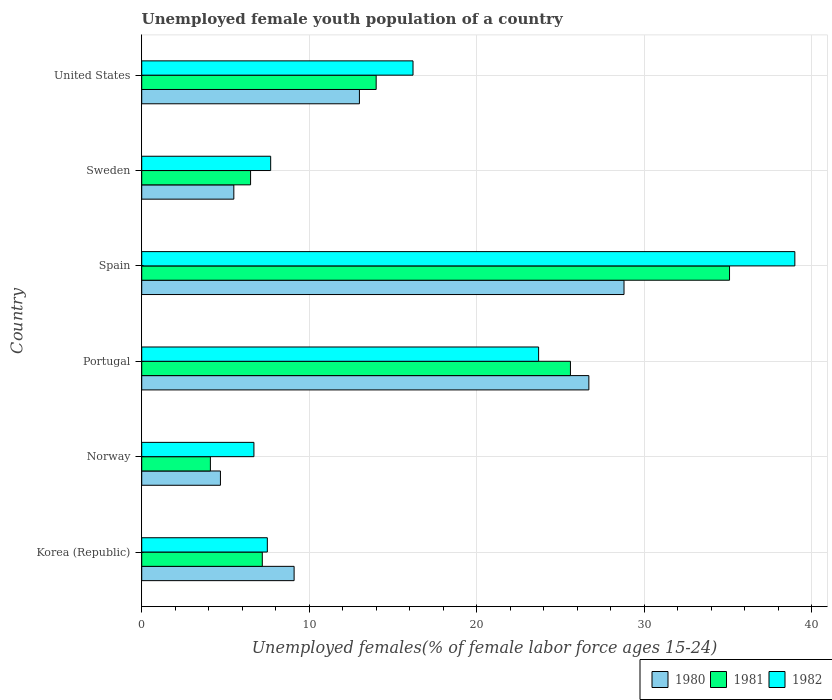Are the number of bars per tick equal to the number of legend labels?
Keep it short and to the point. Yes. How many bars are there on the 6th tick from the top?
Make the answer very short. 3. What is the label of the 1st group of bars from the top?
Give a very brief answer. United States. In how many cases, is the number of bars for a given country not equal to the number of legend labels?
Keep it short and to the point. 0. What is the percentage of unemployed female youth population in 1981 in Norway?
Provide a short and direct response. 4.1. Across all countries, what is the maximum percentage of unemployed female youth population in 1981?
Offer a terse response. 35.1. Across all countries, what is the minimum percentage of unemployed female youth population in 1981?
Your response must be concise. 4.1. In which country was the percentage of unemployed female youth population in 1982 maximum?
Your answer should be very brief. Spain. In which country was the percentage of unemployed female youth population in 1982 minimum?
Keep it short and to the point. Norway. What is the total percentage of unemployed female youth population in 1982 in the graph?
Give a very brief answer. 100.8. What is the difference between the percentage of unemployed female youth population in 1980 in Norway and that in Spain?
Keep it short and to the point. -24.1. What is the difference between the percentage of unemployed female youth population in 1980 in Spain and the percentage of unemployed female youth population in 1981 in Sweden?
Offer a very short reply. 22.3. What is the average percentage of unemployed female youth population in 1982 per country?
Keep it short and to the point. 16.8. What is the difference between the percentage of unemployed female youth population in 1981 and percentage of unemployed female youth population in 1980 in Spain?
Make the answer very short. 6.3. In how many countries, is the percentage of unemployed female youth population in 1982 greater than 4 %?
Your response must be concise. 6. What is the ratio of the percentage of unemployed female youth population in 1981 in Korea (Republic) to that in Norway?
Offer a terse response. 1.76. Is the difference between the percentage of unemployed female youth population in 1981 in Korea (Republic) and United States greater than the difference between the percentage of unemployed female youth population in 1980 in Korea (Republic) and United States?
Offer a very short reply. No. What is the difference between the highest and the second highest percentage of unemployed female youth population in 1981?
Keep it short and to the point. 9.5. What is the difference between the highest and the lowest percentage of unemployed female youth population in 1980?
Your answer should be compact. 24.1. In how many countries, is the percentage of unemployed female youth population in 1981 greater than the average percentage of unemployed female youth population in 1981 taken over all countries?
Provide a succinct answer. 2. Is it the case that in every country, the sum of the percentage of unemployed female youth population in 1981 and percentage of unemployed female youth population in 1980 is greater than the percentage of unemployed female youth population in 1982?
Your answer should be very brief. Yes. How many bars are there?
Your response must be concise. 18. Are all the bars in the graph horizontal?
Ensure brevity in your answer.  Yes. How many countries are there in the graph?
Keep it short and to the point. 6. What is the difference between two consecutive major ticks on the X-axis?
Give a very brief answer. 10. Does the graph contain grids?
Your answer should be very brief. Yes. Where does the legend appear in the graph?
Offer a very short reply. Bottom right. How many legend labels are there?
Provide a short and direct response. 3. What is the title of the graph?
Provide a succinct answer. Unemployed female youth population of a country. What is the label or title of the X-axis?
Provide a succinct answer. Unemployed females(% of female labor force ages 15-24). What is the Unemployed females(% of female labor force ages 15-24) of 1980 in Korea (Republic)?
Offer a very short reply. 9.1. What is the Unemployed females(% of female labor force ages 15-24) in 1981 in Korea (Republic)?
Your answer should be compact. 7.2. What is the Unemployed females(% of female labor force ages 15-24) of 1980 in Norway?
Make the answer very short. 4.7. What is the Unemployed females(% of female labor force ages 15-24) of 1981 in Norway?
Keep it short and to the point. 4.1. What is the Unemployed females(% of female labor force ages 15-24) of 1982 in Norway?
Give a very brief answer. 6.7. What is the Unemployed females(% of female labor force ages 15-24) of 1980 in Portugal?
Make the answer very short. 26.7. What is the Unemployed females(% of female labor force ages 15-24) of 1981 in Portugal?
Provide a short and direct response. 25.6. What is the Unemployed females(% of female labor force ages 15-24) in 1982 in Portugal?
Offer a terse response. 23.7. What is the Unemployed females(% of female labor force ages 15-24) in 1980 in Spain?
Your response must be concise. 28.8. What is the Unemployed females(% of female labor force ages 15-24) in 1981 in Spain?
Provide a succinct answer. 35.1. What is the Unemployed females(% of female labor force ages 15-24) of 1982 in Spain?
Offer a terse response. 39. What is the Unemployed females(% of female labor force ages 15-24) in 1980 in Sweden?
Keep it short and to the point. 5.5. What is the Unemployed females(% of female labor force ages 15-24) in 1982 in Sweden?
Your answer should be compact. 7.7. What is the Unemployed females(% of female labor force ages 15-24) of 1980 in United States?
Ensure brevity in your answer.  13. What is the Unemployed females(% of female labor force ages 15-24) of 1982 in United States?
Your answer should be compact. 16.2. Across all countries, what is the maximum Unemployed females(% of female labor force ages 15-24) in 1980?
Your answer should be compact. 28.8. Across all countries, what is the maximum Unemployed females(% of female labor force ages 15-24) of 1981?
Give a very brief answer. 35.1. Across all countries, what is the minimum Unemployed females(% of female labor force ages 15-24) of 1980?
Offer a terse response. 4.7. Across all countries, what is the minimum Unemployed females(% of female labor force ages 15-24) of 1981?
Make the answer very short. 4.1. Across all countries, what is the minimum Unemployed females(% of female labor force ages 15-24) in 1982?
Your response must be concise. 6.7. What is the total Unemployed females(% of female labor force ages 15-24) of 1980 in the graph?
Your answer should be compact. 87.8. What is the total Unemployed females(% of female labor force ages 15-24) of 1981 in the graph?
Give a very brief answer. 92.5. What is the total Unemployed females(% of female labor force ages 15-24) in 1982 in the graph?
Your answer should be compact. 100.8. What is the difference between the Unemployed females(% of female labor force ages 15-24) in 1981 in Korea (Republic) and that in Norway?
Keep it short and to the point. 3.1. What is the difference between the Unemployed females(% of female labor force ages 15-24) in 1980 in Korea (Republic) and that in Portugal?
Your answer should be compact. -17.6. What is the difference between the Unemployed females(% of female labor force ages 15-24) of 1981 in Korea (Republic) and that in Portugal?
Offer a very short reply. -18.4. What is the difference between the Unemployed females(% of female labor force ages 15-24) of 1982 in Korea (Republic) and that in Portugal?
Ensure brevity in your answer.  -16.2. What is the difference between the Unemployed females(% of female labor force ages 15-24) in 1980 in Korea (Republic) and that in Spain?
Your response must be concise. -19.7. What is the difference between the Unemployed females(% of female labor force ages 15-24) in 1981 in Korea (Republic) and that in Spain?
Give a very brief answer. -27.9. What is the difference between the Unemployed females(% of female labor force ages 15-24) of 1982 in Korea (Republic) and that in Spain?
Your answer should be very brief. -31.5. What is the difference between the Unemployed females(% of female labor force ages 15-24) in 1980 in Korea (Republic) and that in Sweden?
Your response must be concise. 3.6. What is the difference between the Unemployed females(% of female labor force ages 15-24) of 1981 in Korea (Republic) and that in Sweden?
Your response must be concise. 0.7. What is the difference between the Unemployed females(% of female labor force ages 15-24) of 1982 in Korea (Republic) and that in Sweden?
Your response must be concise. -0.2. What is the difference between the Unemployed females(% of female labor force ages 15-24) of 1980 in Korea (Republic) and that in United States?
Your response must be concise. -3.9. What is the difference between the Unemployed females(% of female labor force ages 15-24) of 1980 in Norway and that in Portugal?
Give a very brief answer. -22. What is the difference between the Unemployed females(% of female labor force ages 15-24) of 1981 in Norway and that in Portugal?
Provide a short and direct response. -21.5. What is the difference between the Unemployed females(% of female labor force ages 15-24) of 1980 in Norway and that in Spain?
Your response must be concise. -24.1. What is the difference between the Unemployed females(% of female labor force ages 15-24) in 1981 in Norway and that in Spain?
Your answer should be compact. -31. What is the difference between the Unemployed females(% of female labor force ages 15-24) of 1982 in Norway and that in Spain?
Offer a very short reply. -32.3. What is the difference between the Unemployed females(% of female labor force ages 15-24) of 1980 in Norway and that in Sweden?
Offer a terse response. -0.8. What is the difference between the Unemployed females(% of female labor force ages 15-24) in 1981 in Norway and that in United States?
Your answer should be very brief. -9.9. What is the difference between the Unemployed females(% of female labor force ages 15-24) of 1980 in Portugal and that in Spain?
Your response must be concise. -2.1. What is the difference between the Unemployed females(% of female labor force ages 15-24) of 1982 in Portugal and that in Spain?
Ensure brevity in your answer.  -15.3. What is the difference between the Unemployed females(% of female labor force ages 15-24) in 1980 in Portugal and that in Sweden?
Give a very brief answer. 21.2. What is the difference between the Unemployed females(% of female labor force ages 15-24) in 1981 in Portugal and that in Sweden?
Make the answer very short. 19.1. What is the difference between the Unemployed females(% of female labor force ages 15-24) in 1982 in Portugal and that in Sweden?
Your answer should be compact. 16. What is the difference between the Unemployed females(% of female labor force ages 15-24) of 1980 in Portugal and that in United States?
Offer a very short reply. 13.7. What is the difference between the Unemployed females(% of female labor force ages 15-24) in 1980 in Spain and that in Sweden?
Keep it short and to the point. 23.3. What is the difference between the Unemployed females(% of female labor force ages 15-24) in 1981 in Spain and that in Sweden?
Provide a short and direct response. 28.6. What is the difference between the Unemployed females(% of female labor force ages 15-24) of 1982 in Spain and that in Sweden?
Your response must be concise. 31.3. What is the difference between the Unemployed females(% of female labor force ages 15-24) in 1981 in Spain and that in United States?
Your answer should be very brief. 21.1. What is the difference between the Unemployed females(% of female labor force ages 15-24) in 1982 in Spain and that in United States?
Your response must be concise. 22.8. What is the difference between the Unemployed females(% of female labor force ages 15-24) of 1981 in Korea (Republic) and the Unemployed females(% of female labor force ages 15-24) of 1982 in Norway?
Your answer should be very brief. 0.5. What is the difference between the Unemployed females(% of female labor force ages 15-24) in 1980 in Korea (Republic) and the Unemployed females(% of female labor force ages 15-24) in 1981 in Portugal?
Your answer should be compact. -16.5. What is the difference between the Unemployed females(% of female labor force ages 15-24) in 1980 in Korea (Republic) and the Unemployed females(% of female labor force ages 15-24) in 1982 in Portugal?
Provide a succinct answer. -14.6. What is the difference between the Unemployed females(% of female labor force ages 15-24) of 1981 in Korea (Republic) and the Unemployed females(% of female labor force ages 15-24) of 1982 in Portugal?
Provide a short and direct response. -16.5. What is the difference between the Unemployed females(% of female labor force ages 15-24) of 1980 in Korea (Republic) and the Unemployed females(% of female labor force ages 15-24) of 1982 in Spain?
Offer a very short reply. -29.9. What is the difference between the Unemployed females(% of female labor force ages 15-24) in 1981 in Korea (Republic) and the Unemployed females(% of female labor force ages 15-24) in 1982 in Spain?
Your answer should be compact. -31.8. What is the difference between the Unemployed females(% of female labor force ages 15-24) of 1980 in Norway and the Unemployed females(% of female labor force ages 15-24) of 1981 in Portugal?
Provide a succinct answer. -20.9. What is the difference between the Unemployed females(% of female labor force ages 15-24) in 1980 in Norway and the Unemployed females(% of female labor force ages 15-24) in 1982 in Portugal?
Make the answer very short. -19. What is the difference between the Unemployed females(% of female labor force ages 15-24) of 1981 in Norway and the Unemployed females(% of female labor force ages 15-24) of 1982 in Portugal?
Provide a succinct answer. -19.6. What is the difference between the Unemployed females(% of female labor force ages 15-24) in 1980 in Norway and the Unemployed females(% of female labor force ages 15-24) in 1981 in Spain?
Offer a terse response. -30.4. What is the difference between the Unemployed females(% of female labor force ages 15-24) in 1980 in Norway and the Unemployed females(% of female labor force ages 15-24) in 1982 in Spain?
Keep it short and to the point. -34.3. What is the difference between the Unemployed females(% of female labor force ages 15-24) of 1981 in Norway and the Unemployed females(% of female labor force ages 15-24) of 1982 in Spain?
Ensure brevity in your answer.  -34.9. What is the difference between the Unemployed females(% of female labor force ages 15-24) in 1980 in Norway and the Unemployed females(% of female labor force ages 15-24) in 1981 in Sweden?
Your answer should be compact. -1.8. What is the difference between the Unemployed females(% of female labor force ages 15-24) of 1980 in Norway and the Unemployed females(% of female labor force ages 15-24) of 1982 in Sweden?
Your answer should be very brief. -3. What is the difference between the Unemployed females(% of female labor force ages 15-24) of 1980 in Norway and the Unemployed females(% of female labor force ages 15-24) of 1982 in United States?
Give a very brief answer. -11.5. What is the difference between the Unemployed females(% of female labor force ages 15-24) in 1980 in Portugal and the Unemployed females(% of female labor force ages 15-24) in 1981 in Spain?
Make the answer very short. -8.4. What is the difference between the Unemployed females(% of female labor force ages 15-24) in 1980 in Portugal and the Unemployed females(% of female labor force ages 15-24) in 1982 in Spain?
Give a very brief answer. -12.3. What is the difference between the Unemployed females(% of female labor force ages 15-24) of 1980 in Portugal and the Unemployed females(% of female labor force ages 15-24) of 1981 in Sweden?
Provide a short and direct response. 20.2. What is the difference between the Unemployed females(% of female labor force ages 15-24) in 1980 in Portugal and the Unemployed females(% of female labor force ages 15-24) in 1982 in Sweden?
Provide a succinct answer. 19. What is the difference between the Unemployed females(% of female labor force ages 15-24) of 1980 in Portugal and the Unemployed females(% of female labor force ages 15-24) of 1982 in United States?
Give a very brief answer. 10.5. What is the difference between the Unemployed females(% of female labor force ages 15-24) in 1981 in Portugal and the Unemployed females(% of female labor force ages 15-24) in 1982 in United States?
Offer a terse response. 9.4. What is the difference between the Unemployed females(% of female labor force ages 15-24) in 1980 in Spain and the Unemployed females(% of female labor force ages 15-24) in 1981 in Sweden?
Ensure brevity in your answer.  22.3. What is the difference between the Unemployed females(% of female labor force ages 15-24) of 1980 in Spain and the Unemployed females(% of female labor force ages 15-24) of 1982 in Sweden?
Ensure brevity in your answer.  21.1. What is the difference between the Unemployed females(% of female labor force ages 15-24) of 1981 in Spain and the Unemployed females(% of female labor force ages 15-24) of 1982 in Sweden?
Offer a very short reply. 27.4. What is the difference between the Unemployed females(% of female labor force ages 15-24) in 1981 in Sweden and the Unemployed females(% of female labor force ages 15-24) in 1982 in United States?
Make the answer very short. -9.7. What is the average Unemployed females(% of female labor force ages 15-24) in 1980 per country?
Make the answer very short. 14.63. What is the average Unemployed females(% of female labor force ages 15-24) of 1981 per country?
Ensure brevity in your answer.  15.42. What is the average Unemployed females(% of female labor force ages 15-24) in 1982 per country?
Your answer should be compact. 16.8. What is the difference between the Unemployed females(% of female labor force ages 15-24) in 1980 and Unemployed females(% of female labor force ages 15-24) in 1981 in Korea (Republic)?
Make the answer very short. 1.9. What is the difference between the Unemployed females(% of female labor force ages 15-24) of 1980 and Unemployed females(% of female labor force ages 15-24) of 1981 in Portugal?
Offer a terse response. 1.1. What is the difference between the Unemployed females(% of female labor force ages 15-24) in 1981 and Unemployed females(% of female labor force ages 15-24) in 1982 in Portugal?
Your response must be concise. 1.9. What is the difference between the Unemployed females(% of female labor force ages 15-24) of 1980 and Unemployed females(% of female labor force ages 15-24) of 1982 in Spain?
Ensure brevity in your answer.  -10.2. What is the difference between the Unemployed females(% of female labor force ages 15-24) in 1981 and Unemployed females(% of female labor force ages 15-24) in 1982 in Spain?
Offer a terse response. -3.9. What is the difference between the Unemployed females(% of female labor force ages 15-24) in 1981 and Unemployed females(% of female labor force ages 15-24) in 1982 in Sweden?
Your answer should be very brief. -1.2. What is the difference between the Unemployed females(% of female labor force ages 15-24) of 1980 and Unemployed females(% of female labor force ages 15-24) of 1981 in United States?
Keep it short and to the point. -1. What is the ratio of the Unemployed females(% of female labor force ages 15-24) in 1980 in Korea (Republic) to that in Norway?
Offer a very short reply. 1.94. What is the ratio of the Unemployed females(% of female labor force ages 15-24) of 1981 in Korea (Republic) to that in Norway?
Your answer should be very brief. 1.76. What is the ratio of the Unemployed females(% of female labor force ages 15-24) in 1982 in Korea (Republic) to that in Norway?
Give a very brief answer. 1.12. What is the ratio of the Unemployed females(% of female labor force ages 15-24) of 1980 in Korea (Republic) to that in Portugal?
Provide a succinct answer. 0.34. What is the ratio of the Unemployed females(% of female labor force ages 15-24) in 1981 in Korea (Republic) to that in Portugal?
Keep it short and to the point. 0.28. What is the ratio of the Unemployed females(% of female labor force ages 15-24) in 1982 in Korea (Republic) to that in Portugal?
Offer a very short reply. 0.32. What is the ratio of the Unemployed females(% of female labor force ages 15-24) in 1980 in Korea (Republic) to that in Spain?
Give a very brief answer. 0.32. What is the ratio of the Unemployed females(% of female labor force ages 15-24) of 1981 in Korea (Republic) to that in Spain?
Give a very brief answer. 0.21. What is the ratio of the Unemployed females(% of female labor force ages 15-24) in 1982 in Korea (Republic) to that in Spain?
Your answer should be very brief. 0.19. What is the ratio of the Unemployed females(% of female labor force ages 15-24) in 1980 in Korea (Republic) to that in Sweden?
Offer a terse response. 1.65. What is the ratio of the Unemployed females(% of female labor force ages 15-24) in 1981 in Korea (Republic) to that in Sweden?
Offer a very short reply. 1.11. What is the ratio of the Unemployed females(% of female labor force ages 15-24) in 1980 in Korea (Republic) to that in United States?
Ensure brevity in your answer.  0.7. What is the ratio of the Unemployed females(% of female labor force ages 15-24) in 1981 in Korea (Republic) to that in United States?
Your answer should be very brief. 0.51. What is the ratio of the Unemployed females(% of female labor force ages 15-24) of 1982 in Korea (Republic) to that in United States?
Provide a succinct answer. 0.46. What is the ratio of the Unemployed females(% of female labor force ages 15-24) of 1980 in Norway to that in Portugal?
Provide a succinct answer. 0.18. What is the ratio of the Unemployed females(% of female labor force ages 15-24) of 1981 in Norway to that in Portugal?
Provide a succinct answer. 0.16. What is the ratio of the Unemployed females(% of female labor force ages 15-24) in 1982 in Norway to that in Portugal?
Provide a short and direct response. 0.28. What is the ratio of the Unemployed females(% of female labor force ages 15-24) in 1980 in Norway to that in Spain?
Your response must be concise. 0.16. What is the ratio of the Unemployed females(% of female labor force ages 15-24) in 1981 in Norway to that in Spain?
Your answer should be very brief. 0.12. What is the ratio of the Unemployed females(% of female labor force ages 15-24) in 1982 in Norway to that in Spain?
Your response must be concise. 0.17. What is the ratio of the Unemployed females(% of female labor force ages 15-24) of 1980 in Norway to that in Sweden?
Your response must be concise. 0.85. What is the ratio of the Unemployed females(% of female labor force ages 15-24) in 1981 in Norway to that in Sweden?
Offer a terse response. 0.63. What is the ratio of the Unemployed females(% of female labor force ages 15-24) of 1982 in Norway to that in Sweden?
Make the answer very short. 0.87. What is the ratio of the Unemployed females(% of female labor force ages 15-24) in 1980 in Norway to that in United States?
Offer a very short reply. 0.36. What is the ratio of the Unemployed females(% of female labor force ages 15-24) of 1981 in Norway to that in United States?
Provide a succinct answer. 0.29. What is the ratio of the Unemployed females(% of female labor force ages 15-24) in 1982 in Norway to that in United States?
Ensure brevity in your answer.  0.41. What is the ratio of the Unemployed females(% of female labor force ages 15-24) of 1980 in Portugal to that in Spain?
Offer a very short reply. 0.93. What is the ratio of the Unemployed females(% of female labor force ages 15-24) of 1981 in Portugal to that in Spain?
Make the answer very short. 0.73. What is the ratio of the Unemployed females(% of female labor force ages 15-24) in 1982 in Portugal to that in Spain?
Give a very brief answer. 0.61. What is the ratio of the Unemployed females(% of female labor force ages 15-24) in 1980 in Portugal to that in Sweden?
Your answer should be compact. 4.85. What is the ratio of the Unemployed females(% of female labor force ages 15-24) of 1981 in Portugal to that in Sweden?
Make the answer very short. 3.94. What is the ratio of the Unemployed females(% of female labor force ages 15-24) of 1982 in Portugal to that in Sweden?
Offer a terse response. 3.08. What is the ratio of the Unemployed females(% of female labor force ages 15-24) of 1980 in Portugal to that in United States?
Your response must be concise. 2.05. What is the ratio of the Unemployed females(% of female labor force ages 15-24) in 1981 in Portugal to that in United States?
Your answer should be very brief. 1.83. What is the ratio of the Unemployed females(% of female labor force ages 15-24) in 1982 in Portugal to that in United States?
Offer a very short reply. 1.46. What is the ratio of the Unemployed females(% of female labor force ages 15-24) of 1980 in Spain to that in Sweden?
Keep it short and to the point. 5.24. What is the ratio of the Unemployed females(% of female labor force ages 15-24) in 1982 in Spain to that in Sweden?
Make the answer very short. 5.06. What is the ratio of the Unemployed females(% of female labor force ages 15-24) in 1980 in Spain to that in United States?
Keep it short and to the point. 2.22. What is the ratio of the Unemployed females(% of female labor force ages 15-24) of 1981 in Spain to that in United States?
Your answer should be very brief. 2.51. What is the ratio of the Unemployed females(% of female labor force ages 15-24) in 1982 in Spain to that in United States?
Keep it short and to the point. 2.41. What is the ratio of the Unemployed females(% of female labor force ages 15-24) of 1980 in Sweden to that in United States?
Your answer should be very brief. 0.42. What is the ratio of the Unemployed females(% of female labor force ages 15-24) in 1981 in Sweden to that in United States?
Your answer should be very brief. 0.46. What is the ratio of the Unemployed females(% of female labor force ages 15-24) of 1982 in Sweden to that in United States?
Provide a succinct answer. 0.48. What is the difference between the highest and the second highest Unemployed females(% of female labor force ages 15-24) in 1981?
Ensure brevity in your answer.  9.5. What is the difference between the highest and the lowest Unemployed females(% of female labor force ages 15-24) of 1980?
Provide a succinct answer. 24.1. What is the difference between the highest and the lowest Unemployed females(% of female labor force ages 15-24) in 1981?
Offer a terse response. 31. What is the difference between the highest and the lowest Unemployed females(% of female labor force ages 15-24) of 1982?
Your response must be concise. 32.3. 